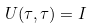Convert formula to latex. <formula><loc_0><loc_0><loc_500><loc_500>U ( \tau , \tau ) = I</formula> 